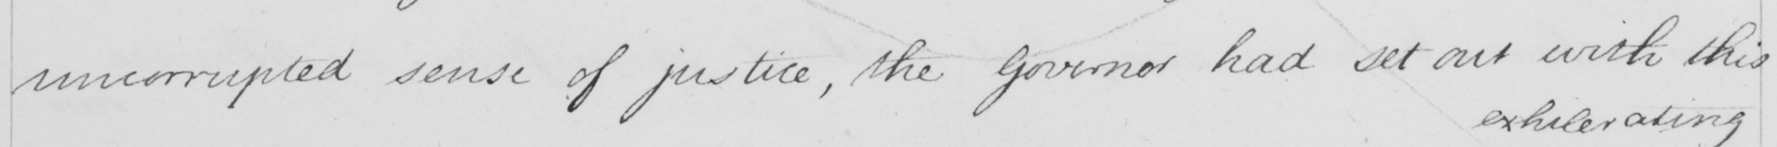Please provide the text content of this handwritten line. uncorrupted sense of justice , the Governor had set out with this 